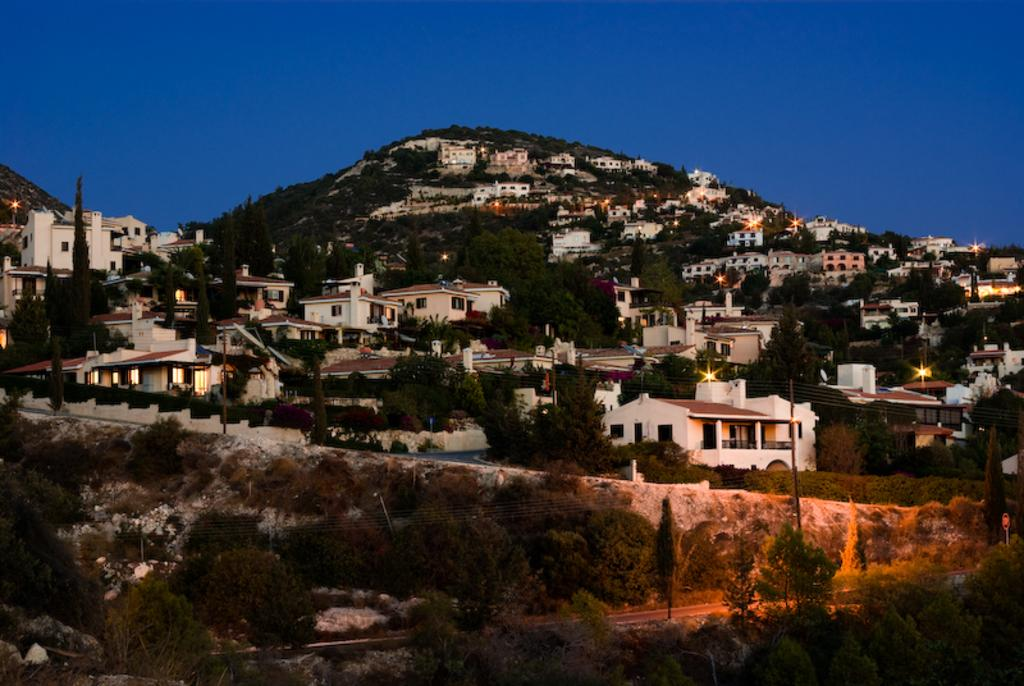What type of structures can be seen in the image? There are buildings in the image. What else is visible in the image besides the buildings? There are lights, poles, a mountain, a road, and the sky visible in the image. Can you describe the lighting in the image? Yes, there are lights visible in the image. What is the natural feature present in the image? There is a mountain in the image. What type of pathway is shown in the image? There is a road in the image. How many zebras can be seen in the room in the image? There is no room or zebras present in the image. What type of border is visible around the mountain in the image? There is no border visible around the mountain in the image; only the mountain itself is present. 